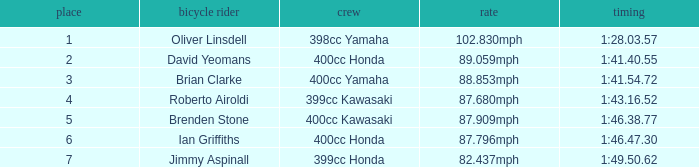What is the time of the rider ranked 6? 1:46.47.30. 